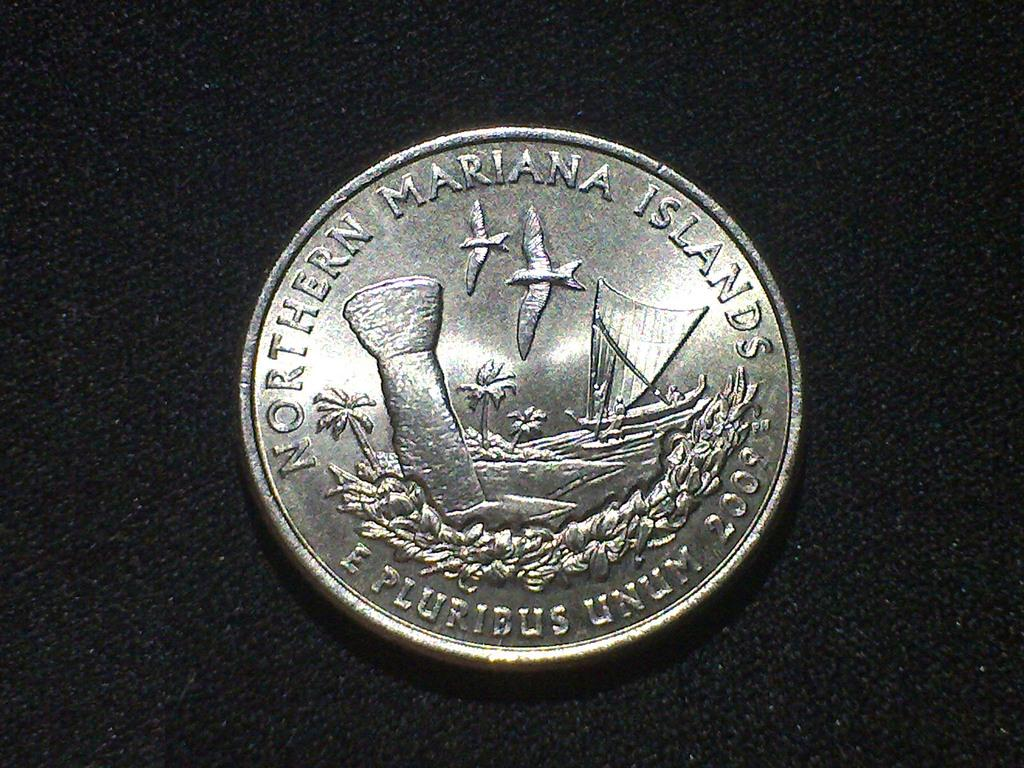<image>
Give a short and clear explanation of the subsequent image. A specially mited coin shows the northern mariana islands. 